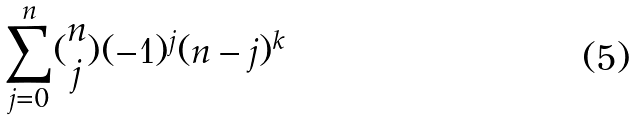Convert formula to latex. <formula><loc_0><loc_0><loc_500><loc_500>\sum _ { j = 0 } ^ { n } ( \begin{matrix} n \\ j \end{matrix} ) ( - 1 ) ^ { j } ( n - j ) ^ { k }</formula> 